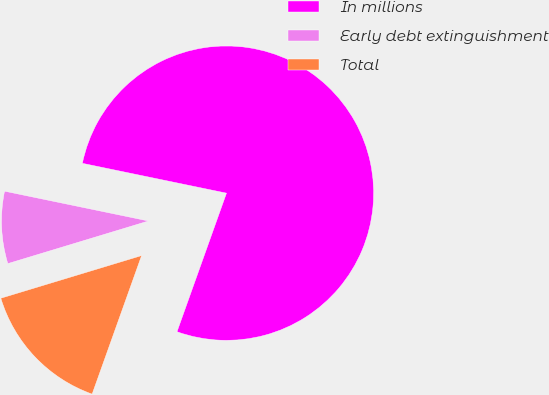Convert chart. <chart><loc_0><loc_0><loc_500><loc_500><pie_chart><fcel>In millions<fcel>Early debt extinguishment<fcel>Total<nl><fcel>77.21%<fcel>7.93%<fcel>14.86%<nl></chart> 